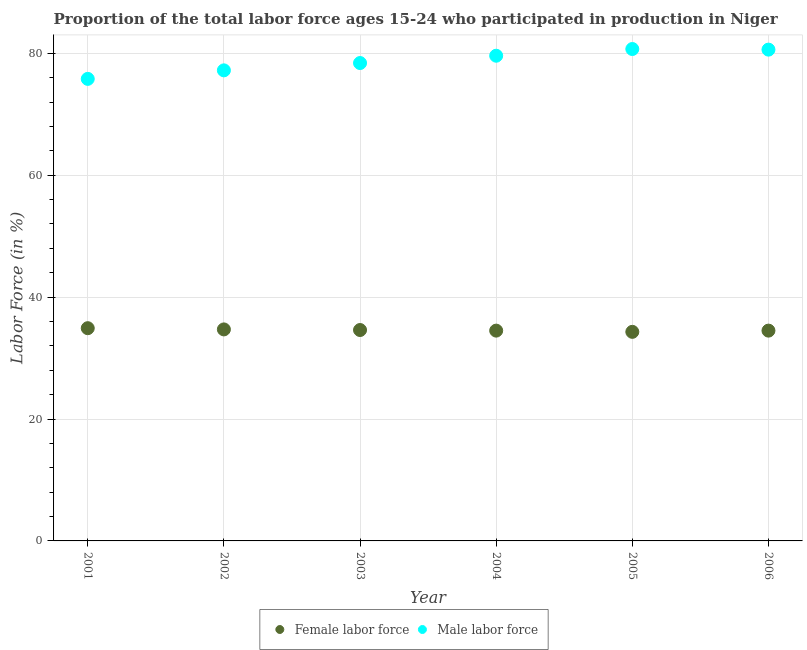Is the number of dotlines equal to the number of legend labels?
Provide a short and direct response. Yes. What is the percentage of male labour force in 2004?
Offer a terse response. 79.6. Across all years, what is the maximum percentage of female labor force?
Your answer should be compact. 34.9. Across all years, what is the minimum percentage of female labor force?
Your answer should be very brief. 34.3. In which year was the percentage of female labor force maximum?
Provide a succinct answer. 2001. What is the total percentage of female labor force in the graph?
Offer a very short reply. 207.5. What is the difference between the percentage of male labour force in 2001 and that in 2006?
Your answer should be compact. -4.8. What is the difference between the percentage of female labor force in 2006 and the percentage of male labour force in 2004?
Give a very brief answer. -45.1. What is the average percentage of female labor force per year?
Provide a succinct answer. 34.58. In the year 2006, what is the difference between the percentage of male labour force and percentage of female labor force?
Your response must be concise. 46.1. What is the ratio of the percentage of female labor force in 2001 to that in 2005?
Ensure brevity in your answer.  1.02. Is the percentage of female labor force in 2003 less than that in 2005?
Offer a very short reply. No. Is the difference between the percentage of female labor force in 2003 and 2005 greater than the difference between the percentage of male labour force in 2003 and 2005?
Your answer should be compact. Yes. What is the difference between the highest and the second highest percentage of female labor force?
Offer a terse response. 0.2. What is the difference between the highest and the lowest percentage of male labour force?
Offer a very short reply. 4.9. Is the sum of the percentage of male labour force in 2004 and 2006 greater than the maximum percentage of female labor force across all years?
Make the answer very short. Yes. Is the percentage of male labour force strictly less than the percentage of female labor force over the years?
Your response must be concise. No. How many years are there in the graph?
Give a very brief answer. 6. What is the difference between two consecutive major ticks on the Y-axis?
Provide a succinct answer. 20. Does the graph contain any zero values?
Your response must be concise. No. Where does the legend appear in the graph?
Make the answer very short. Bottom center. How many legend labels are there?
Make the answer very short. 2. What is the title of the graph?
Your answer should be compact. Proportion of the total labor force ages 15-24 who participated in production in Niger. Does "Banks" appear as one of the legend labels in the graph?
Make the answer very short. No. What is the label or title of the X-axis?
Keep it short and to the point. Year. What is the Labor Force (in %) of Female labor force in 2001?
Provide a succinct answer. 34.9. What is the Labor Force (in %) in Male labor force in 2001?
Ensure brevity in your answer.  75.8. What is the Labor Force (in %) in Female labor force in 2002?
Your answer should be very brief. 34.7. What is the Labor Force (in %) in Male labor force in 2002?
Keep it short and to the point. 77.2. What is the Labor Force (in %) of Female labor force in 2003?
Keep it short and to the point. 34.6. What is the Labor Force (in %) of Male labor force in 2003?
Offer a terse response. 78.4. What is the Labor Force (in %) in Female labor force in 2004?
Your answer should be very brief. 34.5. What is the Labor Force (in %) of Male labor force in 2004?
Provide a succinct answer. 79.6. What is the Labor Force (in %) of Female labor force in 2005?
Keep it short and to the point. 34.3. What is the Labor Force (in %) in Male labor force in 2005?
Provide a short and direct response. 80.7. What is the Labor Force (in %) of Female labor force in 2006?
Provide a succinct answer. 34.5. What is the Labor Force (in %) of Male labor force in 2006?
Ensure brevity in your answer.  80.6. Across all years, what is the maximum Labor Force (in %) of Female labor force?
Give a very brief answer. 34.9. Across all years, what is the maximum Labor Force (in %) in Male labor force?
Your answer should be compact. 80.7. Across all years, what is the minimum Labor Force (in %) of Female labor force?
Make the answer very short. 34.3. Across all years, what is the minimum Labor Force (in %) in Male labor force?
Make the answer very short. 75.8. What is the total Labor Force (in %) in Female labor force in the graph?
Your answer should be very brief. 207.5. What is the total Labor Force (in %) of Male labor force in the graph?
Offer a very short reply. 472.3. What is the difference between the Labor Force (in %) of Female labor force in 2001 and that in 2002?
Ensure brevity in your answer.  0.2. What is the difference between the Labor Force (in %) in Female labor force in 2001 and that in 2003?
Your answer should be very brief. 0.3. What is the difference between the Labor Force (in %) of Female labor force in 2002 and that in 2003?
Provide a succinct answer. 0.1. What is the difference between the Labor Force (in %) in Male labor force in 2002 and that in 2003?
Your answer should be compact. -1.2. What is the difference between the Labor Force (in %) in Female labor force in 2003 and that in 2005?
Provide a succinct answer. 0.3. What is the difference between the Labor Force (in %) in Female labor force in 2004 and that in 2006?
Provide a short and direct response. 0. What is the difference between the Labor Force (in %) of Male labor force in 2004 and that in 2006?
Ensure brevity in your answer.  -1. What is the difference between the Labor Force (in %) in Male labor force in 2005 and that in 2006?
Give a very brief answer. 0.1. What is the difference between the Labor Force (in %) of Female labor force in 2001 and the Labor Force (in %) of Male labor force in 2002?
Give a very brief answer. -42.3. What is the difference between the Labor Force (in %) in Female labor force in 2001 and the Labor Force (in %) in Male labor force in 2003?
Make the answer very short. -43.5. What is the difference between the Labor Force (in %) in Female labor force in 2001 and the Labor Force (in %) in Male labor force in 2004?
Give a very brief answer. -44.7. What is the difference between the Labor Force (in %) in Female labor force in 2001 and the Labor Force (in %) in Male labor force in 2005?
Keep it short and to the point. -45.8. What is the difference between the Labor Force (in %) in Female labor force in 2001 and the Labor Force (in %) in Male labor force in 2006?
Give a very brief answer. -45.7. What is the difference between the Labor Force (in %) of Female labor force in 2002 and the Labor Force (in %) of Male labor force in 2003?
Provide a succinct answer. -43.7. What is the difference between the Labor Force (in %) in Female labor force in 2002 and the Labor Force (in %) in Male labor force in 2004?
Provide a short and direct response. -44.9. What is the difference between the Labor Force (in %) of Female labor force in 2002 and the Labor Force (in %) of Male labor force in 2005?
Provide a succinct answer. -46. What is the difference between the Labor Force (in %) of Female labor force in 2002 and the Labor Force (in %) of Male labor force in 2006?
Give a very brief answer. -45.9. What is the difference between the Labor Force (in %) of Female labor force in 2003 and the Labor Force (in %) of Male labor force in 2004?
Make the answer very short. -45. What is the difference between the Labor Force (in %) in Female labor force in 2003 and the Labor Force (in %) in Male labor force in 2005?
Give a very brief answer. -46.1. What is the difference between the Labor Force (in %) of Female labor force in 2003 and the Labor Force (in %) of Male labor force in 2006?
Your answer should be compact. -46. What is the difference between the Labor Force (in %) of Female labor force in 2004 and the Labor Force (in %) of Male labor force in 2005?
Make the answer very short. -46.2. What is the difference between the Labor Force (in %) in Female labor force in 2004 and the Labor Force (in %) in Male labor force in 2006?
Provide a succinct answer. -46.1. What is the difference between the Labor Force (in %) of Female labor force in 2005 and the Labor Force (in %) of Male labor force in 2006?
Ensure brevity in your answer.  -46.3. What is the average Labor Force (in %) in Female labor force per year?
Your response must be concise. 34.58. What is the average Labor Force (in %) in Male labor force per year?
Your answer should be compact. 78.72. In the year 2001, what is the difference between the Labor Force (in %) of Female labor force and Labor Force (in %) of Male labor force?
Offer a terse response. -40.9. In the year 2002, what is the difference between the Labor Force (in %) of Female labor force and Labor Force (in %) of Male labor force?
Offer a terse response. -42.5. In the year 2003, what is the difference between the Labor Force (in %) of Female labor force and Labor Force (in %) of Male labor force?
Provide a succinct answer. -43.8. In the year 2004, what is the difference between the Labor Force (in %) in Female labor force and Labor Force (in %) in Male labor force?
Offer a terse response. -45.1. In the year 2005, what is the difference between the Labor Force (in %) in Female labor force and Labor Force (in %) in Male labor force?
Provide a succinct answer. -46.4. In the year 2006, what is the difference between the Labor Force (in %) in Female labor force and Labor Force (in %) in Male labor force?
Provide a succinct answer. -46.1. What is the ratio of the Labor Force (in %) of Male labor force in 2001 to that in 2002?
Offer a very short reply. 0.98. What is the ratio of the Labor Force (in %) in Female labor force in 2001 to that in 2003?
Your answer should be very brief. 1.01. What is the ratio of the Labor Force (in %) of Male labor force in 2001 to that in 2003?
Ensure brevity in your answer.  0.97. What is the ratio of the Labor Force (in %) of Female labor force in 2001 to that in 2004?
Give a very brief answer. 1.01. What is the ratio of the Labor Force (in %) of Male labor force in 2001 to that in 2004?
Make the answer very short. 0.95. What is the ratio of the Labor Force (in %) in Female labor force in 2001 to that in 2005?
Give a very brief answer. 1.02. What is the ratio of the Labor Force (in %) of Male labor force in 2001 to that in 2005?
Your answer should be compact. 0.94. What is the ratio of the Labor Force (in %) in Female labor force in 2001 to that in 2006?
Offer a terse response. 1.01. What is the ratio of the Labor Force (in %) in Male labor force in 2001 to that in 2006?
Your response must be concise. 0.94. What is the ratio of the Labor Force (in %) of Female labor force in 2002 to that in 2003?
Provide a succinct answer. 1. What is the ratio of the Labor Force (in %) of Male labor force in 2002 to that in 2003?
Provide a short and direct response. 0.98. What is the ratio of the Labor Force (in %) in Male labor force in 2002 to that in 2004?
Provide a short and direct response. 0.97. What is the ratio of the Labor Force (in %) in Female labor force in 2002 to that in 2005?
Provide a short and direct response. 1.01. What is the ratio of the Labor Force (in %) of Male labor force in 2002 to that in 2005?
Provide a succinct answer. 0.96. What is the ratio of the Labor Force (in %) of Male labor force in 2002 to that in 2006?
Offer a terse response. 0.96. What is the ratio of the Labor Force (in %) in Female labor force in 2003 to that in 2004?
Provide a succinct answer. 1. What is the ratio of the Labor Force (in %) in Male labor force in 2003 to that in 2004?
Offer a very short reply. 0.98. What is the ratio of the Labor Force (in %) in Female labor force in 2003 to that in 2005?
Your answer should be very brief. 1.01. What is the ratio of the Labor Force (in %) of Male labor force in 2003 to that in 2005?
Make the answer very short. 0.97. What is the ratio of the Labor Force (in %) of Male labor force in 2003 to that in 2006?
Your answer should be compact. 0.97. What is the ratio of the Labor Force (in %) of Female labor force in 2004 to that in 2005?
Your response must be concise. 1.01. What is the ratio of the Labor Force (in %) in Male labor force in 2004 to that in 2005?
Give a very brief answer. 0.99. What is the ratio of the Labor Force (in %) in Female labor force in 2004 to that in 2006?
Give a very brief answer. 1. What is the ratio of the Labor Force (in %) in Male labor force in 2004 to that in 2006?
Provide a short and direct response. 0.99. What is the difference between the highest and the second highest Labor Force (in %) of Female labor force?
Ensure brevity in your answer.  0.2. What is the difference between the highest and the second highest Labor Force (in %) of Male labor force?
Ensure brevity in your answer.  0.1. 